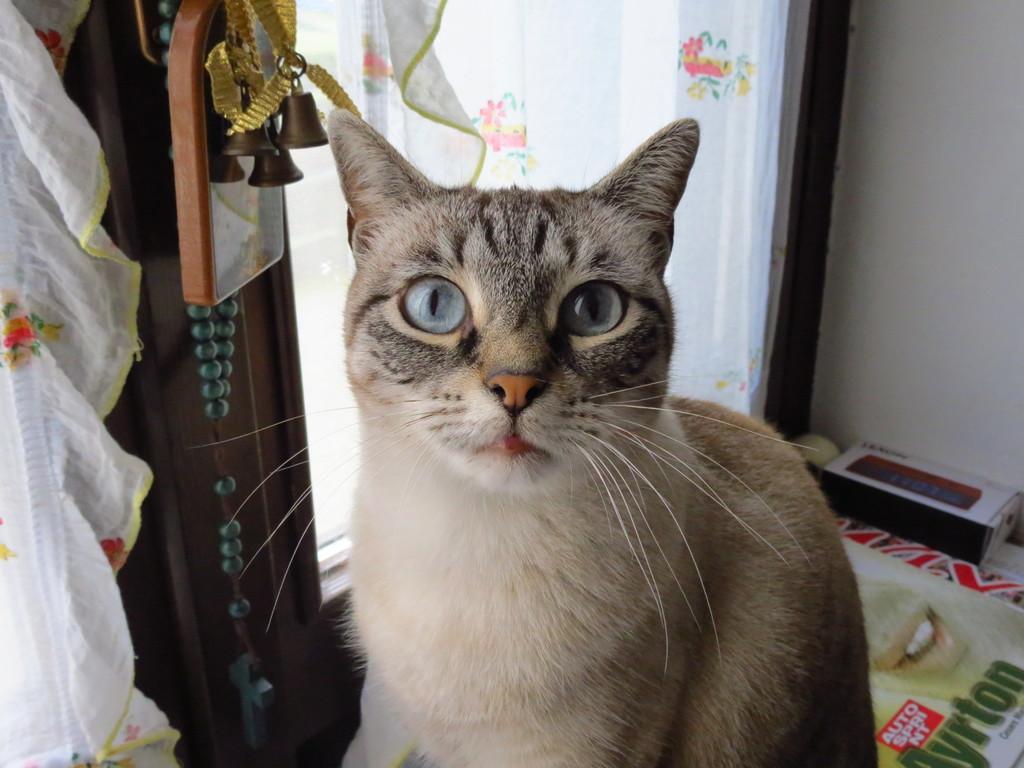In one or two sentences, can you explain what this image depicts? In this image there is a cat in the middle. On the left side top there is a mirror. In front of the mirror there are bells. In the background there is a button. At the bottom there is a mat on which there is a box. 